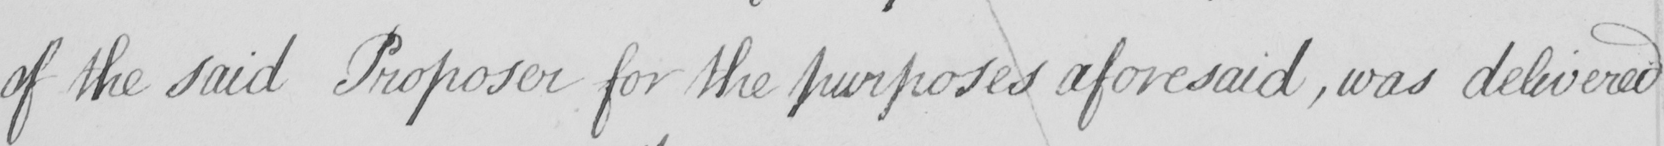Please provide the text content of this handwritten line. of the said Proposer for the purposes aforesaid  , was delivered 